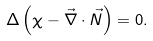<formula> <loc_0><loc_0><loc_500><loc_500>\Delta \left ( \chi - \vec { \nabla } \cdot \vec { N } \right ) = 0 .</formula> 